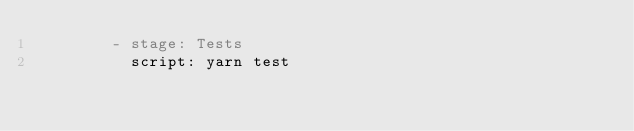<code> <loc_0><loc_0><loc_500><loc_500><_YAML_>        - stage: Tests
          script: yarn test
</code> 